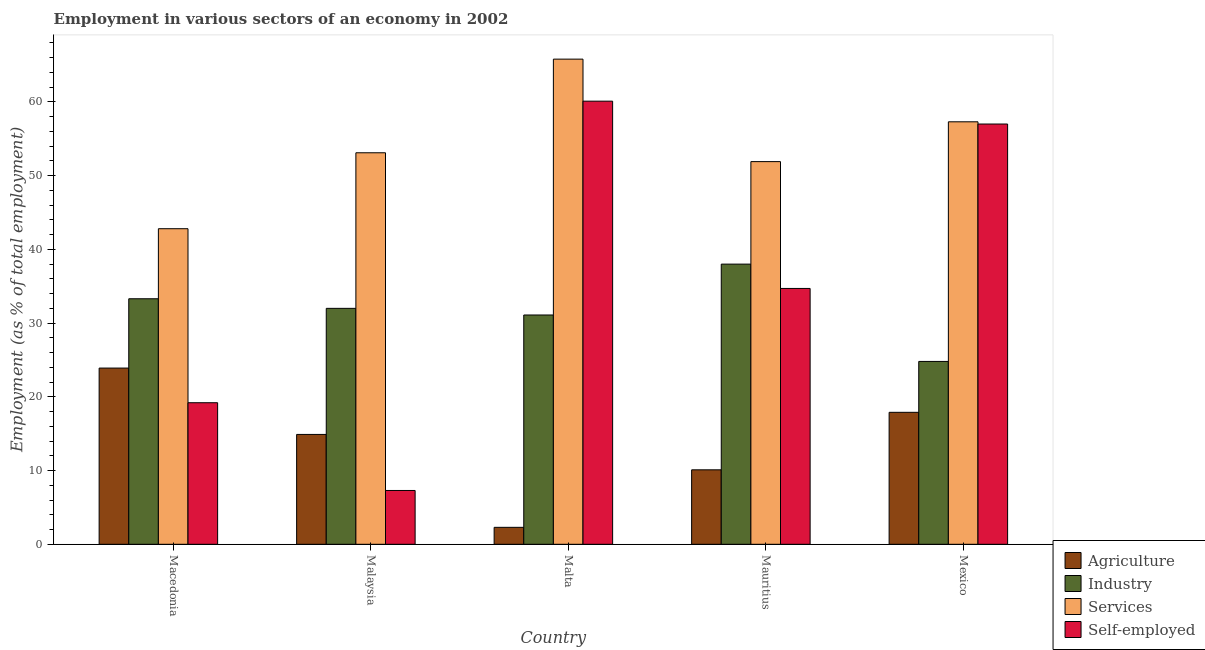How many groups of bars are there?
Provide a succinct answer. 5. Are the number of bars on each tick of the X-axis equal?
Your answer should be very brief. Yes. How many bars are there on the 1st tick from the right?
Your answer should be very brief. 4. What is the label of the 3rd group of bars from the left?
Offer a terse response. Malta. In how many cases, is the number of bars for a given country not equal to the number of legend labels?
Ensure brevity in your answer.  0. What is the percentage of self employed workers in Macedonia?
Provide a short and direct response. 19.2. Across all countries, what is the maximum percentage of self employed workers?
Provide a short and direct response. 60.1. Across all countries, what is the minimum percentage of self employed workers?
Your answer should be very brief. 7.3. In which country was the percentage of workers in industry maximum?
Your answer should be compact. Mauritius. In which country was the percentage of workers in agriculture minimum?
Keep it short and to the point. Malta. What is the total percentage of workers in agriculture in the graph?
Your response must be concise. 69.1. What is the difference between the percentage of self employed workers in Mauritius and that in Mexico?
Provide a short and direct response. -22.3. What is the difference between the percentage of self employed workers in Mexico and the percentage of workers in agriculture in Macedonia?
Provide a short and direct response. 33.1. What is the average percentage of workers in services per country?
Provide a short and direct response. 54.18. What is the difference between the percentage of workers in industry and percentage of workers in agriculture in Mexico?
Offer a terse response. 6.9. In how many countries, is the percentage of workers in agriculture greater than 54 %?
Keep it short and to the point. 0. What is the ratio of the percentage of workers in services in Macedonia to that in Mauritius?
Give a very brief answer. 0.82. Is the percentage of self employed workers in Malaysia less than that in Mauritius?
Offer a terse response. Yes. Is the difference between the percentage of workers in agriculture in Mauritius and Mexico greater than the difference between the percentage of workers in industry in Mauritius and Mexico?
Ensure brevity in your answer.  No. What is the difference between the highest and the second highest percentage of workers in industry?
Offer a terse response. 4.7. What is the difference between the highest and the lowest percentage of self employed workers?
Your response must be concise. 52.8. What does the 1st bar from the left in Macedonia represents?
Give a very brief answer. Agriculture. What does the 3rd bar from the right in Malta represents?
Provide a short and direct response. Industry. Is it the case that in every country, the sum of the percentage of workers in agriculture and percentage of workers in industry is greater than the percentage of workers in services?
Offer a very short reply. No. How many bars are there?
Provide a succinct answer. 20. Are all the bars in the graph horizontal?
Make the answer very short. No. How many countries are there in the graph?
Provide a short and direct response. 5. Are the values on the major ticks of Y-axis written in scientific E-notation?
Ensure brevity in your answer.  No. Does the graph contain grids?
Provide a short and direct response. No. How many legend labels are there?
Provide a short and direct response. 4. What is the title of the graph?
Keep it short and to the point. Employment in various sectors of an economy in 2002. What is the label or title of the X-axis?
Give a very brief answer. Country. What is the label or title of the Y-axis?
Provide a short and direct response. Employment (as % of total employment). What is the Employment (as % of total employment) in Agriculture in Macedonia?
Offer a terse response. 23.9. What is the Employment (as % of total employment) of Industry in Macedonia?
Offer a terse response. 33.3. What is the Employment (as % of total employment) of Services in Macedonia?
Offer a very short reply. 42.8. What is the Employment (as % of total employment) of Self-employed in Macedonia?
Your answer should be very brief. 19.2. What is the Employment (as % of total employment) in Agriculture in Malaysia?
Make the answer very short. 14.9. What is the Employment (as % of total employment) in Industry in Malaysia?
Your answer should be very brief. 32. What is the Employment (as % of total employment) in Services in Malaysia?
Give a very brief answer. 53.1. What is the Employment (as % of total employment) of Self-employed in Malaysia?
Offer a very short reply. 7.3. What is the Employment (as % of total employment) in Agriculture in Malta?
Your response must be concise. 2.3. What is the Employment (as % of total employment) of Industry in Malta?
Ensure brevity in your answer.  31.1. What is the Employment (as % of total employment) in Services in Malta?
Offer a terse response. 65.8. What is the Employment (as % of total employment) in Self-employed in Malta?
Keep it short and to the point. 60.1. What is the Employment (as % of total employment) in Agriculture in Mauritius?
Your answer should be very brief. 10.1. What is the Employment (as % of total employment) in Industry in Mauritius?
Offer a terse response. 38. What is the Employment (as % of total employment) of Services in Mauritius?
Make the answer very short. 51.9. What is the Employment (as % of total employment) of Self-employed in Mauritius?
Keep it short and to the point. 34.7. What is the Employment (as % of total employment) of Agriculture in Mexico?
Make the answer very short. 17.9. What is the Employment (as % of total employment) of Industry in Mexico?
Keep it short and to the point. 24.8. What is the Employment (as % of total employment) of Services in Mexico?
Offer a very short reply. 57.3. What is the Employment (as % of total employment) of Self-employed in Mexico?
Offer a terse response. 57. Across all countries, what is the maximum Employment (as % of total employment) in Agriculture?
Offer a terse response. 23.9. Across all countries, what is the maximum Employment (as % of total employment) in Industry?
Provide a succinct answer. 38. Across all countries, what is the maximum Employment (as % of total employment) of Services?
Give a very brief answer. 65.8. Across all countries, what is the maximum Employment (as % of total employment) in Self-employed?
Your response must be concise. 60.1. Across all countries, what is the minimum Employment (as % of total employment) of Agriculture?
Make the answer very short. 2.3. Across all countries, what is the minimum Employment (as % of total employment) of Industry?
Your answer should be very brief. 24.8. Across all countries, what is the minimum Employment (as % of total employment) of Services?
Provide a succinct answer. 42.8. Across all countries, what is the minimum Employment (as % of total employment) of Self-employed?
Provide a short and direct response. 7.3. What is the total Employment (as % of total employment) in Agriculture in the graph?
Ensure brevity in your answer.  69.1. What is the total Employment (as % of total employment) in Industry in the graph?
Make the answer very short. 159.2. What is the total Employment (as % of total employment) in Services in the graph?
Provide a short and direct response. 270.9. What is the total Employment (as % of total employment) in Self-employed in the graph?
Your response must be concise. 178.3. What is the difference between the Employment (as % of total employment) of Agriculture in Macedonia and that in Malaysia?
Keep it short and to the point. 9. What is the difference between the Employment (as % of total employment) of Self-employed in Macedonia and that in Malaysia?
Ensure brevity in your answer.  11.9. What is the difference between the Employment (as % of total employment) in Agriculture in Macedonia and that in Malta?
Provide a succinct answer. 21.6. What is the difference between the Employment (as % of total employment) of Industry in Macedonia and that in Malta?
Your response must be concise. 2.2. What is the difference between the Employment (as % of total employment) of Self-employed in Macedonia and that in Malta?
Keep it short and to the point. -40.9. What is the difference between the Employment (as % of total employment) in Services in Macedonia and that in Mauritius?
Provide a succinct answer. -9.1. What is the difference between the Employment (as % of total employment) of Self-employed in Macedonia and that in Mauritius?
Provide a short and direct response. -15.5. What is the difference between the Employment (as % of total employment) of Agriculture in Macedonia and that in Mexico?
Your answer should be compact. 6. What is the difference between the Employment (as % of total employment) of Industry in Macedonia and that in Mexico?
Offer a very short reply. 8.5. What is the difference between the Employment (as % of total employment) of Services in Macedonia and that in Mexico?
Offer a terse response. -14.5. What is the difference between the Employment (as % of total employment) of Self-employed in Macedonia and that in Mexico?
Keep it short and to the point. -37.8. What is the difference between the Employment (as % of total employment) in Industry in Malaysia and that in Malta?
Your answer should be very brief. 0.9. What is the difference between the Employment (as % of total employment) in Services in Malaysia and that in Malta?
Your answer should be very brief. -12.7. What is the difference between the Employment (as % of total employment) in Self-employed in Malaysia and that in Malta?
Ensure brevity in your answer.  -52.8. What is the difference between the Employment (as % of total employment) in Industry in Malaysia and that in Mauritius?
Your response must be concise. -6. What is the difference between the Employment (as % of total employment) of Self-employed in Malaysia and that in Mauritius?
Provide a short and direct response. -27.4. What is the difference between the Employment (as % of total employment) in Self-employed in Malaysia and that in Mexico?
Provide a short and direct response. -49.7. What is the difference between the Employment (as % of total employment) in Agriculture in Malta and that in Mauritius?
Offer a very short reply. -7.8. What is the difference between the Employment (as % of total employment) in Industry in Malta and that in Mauritius?
Keep it short and to the point. -6.9. What is the difference between the Employment (as % of total employment) in Services in Malta and that in Mauritius?
Provide a succinct answer. 13.9. What is the difference between the Employment (as % of total employment) in Self-employed in Malta and that in Mauritius?
Your answer should be compact. 25.4. What is the difference between the Employment (as % of total employment) of Agriculture in Malta and that in Mexico?
Provide a succinct answer. -15.6. What is the difference between the Employment (as % of total employment) in Industry in Malta and that in Mexico?
Your answer should be compact. 6.3. What is the difference between the Employment (as % of total employment) of Services in Malta and that in Mexico?
Provide a short and direct response. 8.5. What is the difference between the Employment (as % of total employment) in Self-employed in Malta and that in Mexico?
Provide a short and direct response. 3.1. What is the difference between the Employment (as % of total employment) in Industry in Mauritius and that in Mexico?
Give a very brief answer. 13.2. What is the difference between the Employment (as % of total employment) in Services in Mauritius and that in Mexico?
Your answer should be compact. -5.4. What is the difference between the Employment (as % of total employment) of Self-employed in Mauritius and that in Mexico?
Your answer should be very brief. -22.3. What is the difference between the Employment (as % of total employment) of Agriculture in Macedonia and the Employment (as % of total employment) of Services in Malaysia?
Offer a terse response. -29.2. What is the difference between the Employment (as % of total employment) in Industry in Macedonia and the Employment (as % of total employment) in Services in Malaysia?
Your answer should be very brief. -19.8. What is the difference between the Employment (as % of total employment) in Industry in Macedonia and the Employment (as % of total employment) in Self-employed in Malaysia?
Offer a terse response. 26. What is the difference between the Employment (as % of total employment) of Services in Macedonia and the Employment (as % of total employment) of Self-employed in Malaysia?
Give a very brief answer. 35.5. What is the difference between the Employment (as % of total employment) in Agriculture in Macedonia and the Employment (as % of total employment) in Industry in Malta?
Give a very brief answer. -7.2. What is the difference between the Employment (as % of total employment) in Agriculture in Macedonia and the Employment (as % of total employment) in Services in Malta?
Give a very brief answer. -41.9. What is the difference between the Employment (as % of total employment) in Agriculture in Macedonia and the Employment (as % of total employment) in Self-employed in Malta?
Your response must be concise. -36.2. What is the difference between the Employment (as % of total employment) in Industry in Macedonia and the Employment (as % of total employment) in Services in Malta?
Make the answer very short. -32.5. What is the difference between the Employment (as % of total employment) in Industry in Macedonia and the Employment (as % of total employment) in Self-employed in Malta?
Make the answer very short. -26.8. What is the difference between the Employment (as % of total employment) in Services in Macedonia and the Employment (as % of total employment) in Self-employed in Malta?
Provide a succinct answer. -17.3. What is the difference between the Employment (as % of total employment) in Agriculture in Macedonia and the Employment (as % of total employment) in Industry in Mauritius?
Offer a terse response. -14.1. What is the difference between the Employment (as % of total employment) of Industry in Macedonia and the Employment (as % of total employment) of Services in Mauritius?
Provide a succinct answer. -18.6. What is the difference between the Employment (as % of total employment) of Industry in Macedonia and the Employment (as % of total employment) of Self-employed in Mauritius?
Keep it short and to the point. -1.4. What is the difference between the Employment (as % of total employment) in Services in Macedonia and the Employment (as % of total employment) in Self-employed in Mauritius?
Ensure brevity in your answer.  8.1. What is the difference between the Employment (as % of total employment) of Agriculture in Macedonia and the Employment (as % of total employment) of Industry in Mexico?
Offer a very short reply. -0.9. What is the difference between the Employment (as % of total employment) in Agriculture in Macedonia and the Employment (as % of total employment) in Services in Mexico?
Make the answer very short. -33.4. What is the difference between the Employment (as % of total employment) in Agriculture in Macedonia and the Employment (as % of total employment) in Self-employed in Mexico?
Provide a succinct answer. -33.1. What is the difference between the Employment (as % of total employment) of Industry in Macedonia and the Employment (as % of total employment) of Self-employed in Mexico?
Offer a very short reply. -23.7. What is the difference between the Employment (as % of total employment) in Services in Macedonia and the Employment (as % of total employment) in Self-employed in Mexico?
Provide a succinct answer. -14.2. What is the difference between the Employment (as % of total employment) in Agriculture in Malaysia and the Employment (as % of total employment) in Industry in Malta?
Offer a terse response. -16.2. What is the difference between the Employment (as % of total employment) of Agriculture in Malaysia and the Employment (as % of total employment) of Services in Malta?
Your answer should be compact. -50.9. What is the difference between the Employment (as % of total employment) in Agriculture in Malaysia and the Employment (as % of total employment) in Self-employed in Malta?
Make the answer very short. -45.2. What is the difference between the Employment (as % of total employment) of Industry in Malaysia and the Employment (as % of total employment) of Services in Malta?
Your answer should be compact. -33.8. What is the difference between the Employment (as % of total employment) of Industry in Malaysia and the Employment (as % of total employment) of Self-employed in Malta?
Provide a succinct answer. -28.1. What is the difference between the Employment (as % of total employment) of Agriculture in Malaysia and the Employment (as % of total employment) of Industry in Mauritius?
Your answer should be compact. -23.1. What is the difference between the Employment (as % of total employment) in Agriculture in Malaysia and the Employment (as % of total employment) in Services in Mauritius?
Keep it short and to the point. -37. What is the difference between the Employment (as % of total employment) of Agriculture in Malaysia and the Employment (as % of total employment) of Self-employed in Mauritius?
Your answer should be compact. -19.8. What is the difference between the Employment (as % of total employment) in Industry in Malaysia and the Employment (as % of total employment) in Services in Mauritius?
Make the answer very short. -19.9. What is the difference between the Employment (as % of total employment) of Industry in Malaysia and the Employment (as % of total employment) of Self-employed in Mauritius?
Offer a very short reply. -2.7. What is the difference between the Employment (as % of total employment) of Agriculture in Malaysia and the Employment (as % of total employment) of Services in Mexico?
Keep it short and to the point. -42.4. What is the difference between the Employment (as % of total employment) of Agriculture in Malaysia and the Employment (as % of total employment) of Self-employed in Mexico?
Provide a succinct answer. -42.1. What is the difference between the Employment (as % of total employment) in Industry in Malaysia and the Employment (as % of total employment) in Services in Mexico?
Provide a short and direct response. -25.3. What is the difference between the Employment (as % of total employment) of Industry in Malaysia and the Employment (as % of total employment) of Self-employed in Mexico?
Your answer should be compact. -25. What is the difference between the Employment (as % of total employment) of Services in Malaysia and the Employment (as % of total employment) of Self-employed in Mexico?
Provide a short and direct response. -3.9. What is the difference between the Employment (as % of total employment) of Agriculture in Malta and the Employment (as % of total employment) of Industry in Mauritius?
Provide a short and direct response. -35.7. What is the difference between the Employment (as % of total employment) in Agriculture in Malta and the Employment (as % of total employment) in Services in Mauritius?
Offer a terse response. -49.6. What is the difference between the Employment (as % of total employment) in Agriculture in Malta and the Employment (as % of total employment) in Self-employed in Mauritius?
Provide a succinct answer. -32.4. What is the difference between the Employment (as % of total employment) in Industry in Malta and the Employment (as % of total employment) in Services in Mauritius?
Offer a very short reply. -20.8. What is the difference between the Employment (as % of total employment) in Industry in Malta and the Employment (as % of total employment) in Self-employed in Mauritius?
Provide a succinct answer. -3.6. What is the difference between the Employment (as % of total employment) of Services in Malta and the Employment (as % of total employment) of Self-employed in Mauritius?
Offer a terse response. 31.1. What is the difference between the Employment (as % of total employment) in Agriculture in Malta and the Employment (as % of total employment) in Industry in Mexico?
Make the answer very short. -22.5. What is the difference between the Employment (as % of total employment) in Agriculture in Malta and the Employment (as % of total employment) in Services in Mexico?
Make the answer very short. -55. What is the difference between the Employment (as % of total employment) in Agriculture in Malta and the Employment (as % of total employment) in Self-employed in Mexico?
Keep it short and to the point. -54.7. What is the difference between the Employment (as % of total employment) of Industry in Malta and the Employment (as % of total employment) of Services in Mexico?
Give a very brief answer. -26.2. What is the difference between the Employment (as % of total employment) in Industry in Malta and the Employment (as % of total employment) in Self-employed in Mexico?
Make the answer very short. -25.9. What is the difference between the Employment (as % of total employment) of Services in Malta and the Employment (as % of total employment) of Self-employed in Mexico?
Provide a short and direct response. 8.8. What is the difference between the Employment (as % of total employment) in Agriculture in Mauritius and the Employment (as % of total employment) in Industry in Mexico?
Offer a terse response. -14.7. What is the difference between the Employment (as % of total employment) in Agriculture in Mauritius and the Employment (as % of total employment) in Services in Mexico?
Make the answer very short. -47.2. What is the difference between the Employment (as % of total employment) in Agriculture in Mauritius and the Employment (as % of total employment) in Self-employed in Mexico?
Provide a short and direct response. -46.9. What is the difference between the Employment (as % of total employment) of Industry in Mauritius and the Employment (as % of total employment) of Services in Mexico?
Your answer should be very brief. -19.3. What is the difference between the Employment (as % of total employment) in Industry in Mauritius and the Employment (as % of total employment) in Self-employed in Mexico?
Your response must be concise. -19. What is the difference between the Employment (as % of total employment) of Services in Mauritius and the Employment (as % of total employment) of Self-employed in Mexico?
Offer a terse response. -5.1. What is the average Employment (as % of total employment) of Agriculture per country?
Offer a very short reply. 13.82. What is the average Employment (as % of total employment) in Industry per country?
Your answer should be compact. 31.84. What is the average Employment (as % of total employment) of Services per country?
Your answer should be very brief. 54.18. What is the average Employment (as % of total employment) in Self-employed per country?
Give a very brief answer. 35.66. What is the difference between the Employment (as % of total employment) of Agriculture and Employment (as % of total employment) of Industry in Macedonia?
Your response must be concise. -9.4. What is the difference between the Employment (as % of total employment) in Agriculture and Employment (as % of total employment) in Services in Macedonia?
Give a very brief answer. -18.9. What is the difference between the Employment (as % of total employment) of Industry and Employment (as % of total employment) of Services in Macedonia?
Your answer should be very brief. -9.5. What is the difference between the Employment (as % of total employment) in Industry and Employment (as % of total employment) in Self-employed in Macedonia?
Provide a succinct answer. 14.1. What is the difference between the Employment (as % of total employment) in Services and Employment (as % of total employment) in Self-employed in Macedonia?
Offer a very short reply. 23.6. What is the difference between the Employment (as % of total employment) of Agriculture and Employment (as % of total employment) of Industry in Malaysia?
Provide a succinct answer. -17.1. What is the difference between the Employment (as % of total employment) of Agriculture and Employment (as % of total employment) of Services in Malaysia?
Provide a short and direct response. -38.2. What is the difference between the Employment (as % of total employment) of Agriculture and Employment (as % of total employment) of Self-employed in Malaysia?
Your response must be concise. 7.6. What is the difference between the Employment (as % of total employment) in Industry and Employment (as % of total employment) in Services in Malaysia?
Provide a succinct answer. -21.1. What is the difference between the Employment (as % of total employment) in Industry and Employment (as % of total employment) in Self-employed in Malaysia?
Offer a terse response. 24.7. What is the difference between the Employment (as % of total employment) in Services and Employment (as % of total employment) in Self-employed in Malaysia?
Keep it short and to the point. 45.8. What is the difference between the Employment (as % of total employment) in Agriculture and Employment (as % of total employment) in Industry in Malta?
Keep it short and to the point. -28.8. What is the difference between the Employment (as % of total employment) of Agriculture and Employment (as % of total employment) of Services in Malta?
Ensure brevity in your answer.  -63.5. What is the difference between the Employment (as % of total employment) of Agriculture and Employment (as % of total employment) of Self-employed in Malta?
Ensure brevity in your answer.  -57.8. What is the difference between the Employment (as % of total employment) of Industry and Employment (as % of total employment) of Services in Malta?
Your answer should be compact. -34.7. What is the difference between the Employment (as % of total employment) in Industry and Employment (as % of total employment) in Self-employed in Malta?
Your response must be concise. -29. What is the difference between the Employment (as % of total employment) in Services and Employment (as % of total employment) in Self-employed in Malta?
Your answer should be very brief. 5.7. What is the difference between the Employment (as % of total employment) of Agriculture and Employment (as % of total employment) of Industry in Mauritius?
Provide a short and direct response. -27.9. What is the difference between the Employment (as % of total employment) in Agriculture and Employment (as % of total employment) in Services in Mauritius?
Offer a terse response. -41.8. What is the difference between the Employment (as % of total employment) of Agriculture and Employment (as % of total employment) of Self-employed in Mauritius?
Offer a terse response. -24.6. What is the difference between the Employment (as % of total employment) in Industry and Employment (as % of total employment) in Services in Mauritius?
Your answer should be very brief. -13.9. What is the difference between the Employment (as % of total employment) of Industry and Employment (as % of total employment) of Self-employed in Mauritius?
Offer a terse response. 3.3. What is the difference between the Employment (as % of total employment) in Agriculture and Employment (as % of total employment) in Industry in Mexico?
Offer a very short reply. -6.9. What is the difference between the Employment (as % of total employment) of Agriculture and Employment (as % of total employment) of Services in Mexico?
Your response must be concise. -39.4. What is the difference between the Employment (as % of total employment) of Agriculture and Employment (as % of total employment) of Self-employed in Mexico?
Offer a terse response. -39.1. What is the difference between the Employment (as % of total employment) in Industry and Employment (as % of total employment) in Services in Mexico?
Offer a very short reply. -32.5. What is the difference between the Employment (as % of total employment) in Industry and Employment (as % of total employment) in Self-employed in Mexico?
Ensure brevity in your answer.  -32.2. What is the difference between the Employment (as % of total employment) in Services and Employment (as % of total employment) in Self-employed in Mexico?
Provide a succinct answer. 0.3. What is the ratio of the Employment (as % of total employment) in Agriculture in Macedonia to that in Malaysia?
Your response must be concise. 1.6. What is the ratio of the Employment (as % of total employment) of Industry in Macedonia to that in Malaysia?
Offer a very short reply. 1.04. What is the ratio of the Employment (as % of total employment) of Services in Macedonia to that in Malaysia?
Give a very brief answer. 0.81. What is the ratio of the Employment (as % of total employment) in Self-employed in Macedonia to that in Malaysia?
Make the answer very short. 2.63. What is the ratio of the Employment (as % of total employment) of Agriculture in Macedonia to that in Malta?
Offer a very short reply. 10.39. What is the ratio of the Employment (as % of total employment) of Industry in Macedonia to that in Malta?
Make the answer very short. 1.07. What is the ratio of the Employment (as % of total employment) in Services in Macedonia to that in Malta?
Offer a terse response. 0.65. What is the ratio of the Employment (as % of total employment) in Self-employed in Macedonia to that in Malta?
Provide a succinct answer. 0.32. What is the ratio of the Employment (as % of total employment) of Agriculture in Macedonia to that in Mauritius?
Ensure brevity in your answer.  2.37. What is the ratio of the Employment (as % of total employment) of Industry in Macedonia to that in Mauritius?
Keep it short and to the point. 0.88. What is the ratio of the Employment (as % of total employment) in Services in Macedonia to that in Mauritius?
Your answer should be compact. 0.82. What is the ratio of the Employment (as % of total employment) of Self-employed in Macedonia to that in Mauritius?
Provide a succinct answer. 0.55. What is the ratio of the Employment (as % of total employment) in Agriculture in Macedonia to that in Mexico?
Give a very brief answer. 1.34. What is the ratio of the Employment (as % of total employment) of Industry in Macedonia to that in Mexico?
Provide a succinct answer. 1.34. What is the ratio of the Employment (as % of total employment) in Services in Macedonia to that in Mexico?
Your answer should be compact. 0.75. What is the ratio of the Employment (as % of total employment) in Self-employed in Macedonia to that in Mexico?
Offer a very short reply. 0.34. What is the ratio of the Employment (as % of total employment) in Agriculture in Malaysia to that in Malta?
Ensure brevity in your answer.  6.48. What is the ratio of the Employment (as % of total employment) of Industry in Malaysia to that in Malta?
Offer a very short reply. 1.03. What is the ratio of the Employment (as % of total employment) of Services in Malaysia to that in Malta?
Give a very brief answer. 0.81. What is the ratio of the Employment (as % of total employment) in Self-employed in Malaysia to that in Malta?
Make the answer very short. 0.12. What is the ratio of the Employment (as % of total employment) in Agriculture in Malaysia to that in Mauritius?
Ensure brevity in your answer.  1.48. What is the ratio of the Employment (as % of total employment) of Industry in Malaysia to that in Mauritius?
Offer a very short reply. 0.84. What is the ratio of the Employment (as % of total employment) of Services in Malaysia to that in Mauritius?
Give a very brief answer. 1.02. What is the ratio of the Employment (as % of total employment) in Self-employed in Malaysia to that in Mauritius?
Make the answer very short. 0.21. What is the ratio of the Employment (as % of total employment) in Agriculture in Malaysia to that in Mexico?
Offer a very short reply. 0.83. What is the ratio of the Employment (as % of total employment) of Industry in Malaysia to that in Mexico?
Offer a very short reply. 1.29. What is the ratio of the Employment (as % of total employment) of Services in Malaysia to that in Mexico?
Provide a succinct answer. 0.93. What is the ratio of the Employment (as % of total employment) of Self-employed in Malaysia to that in Mexico?
Offer a terse response. 0.13. What is the ratio of the Employment (as % of total employment) in Agriculture in Malta to that in Mauritius?
Your answer should be very brief. 0.23. What is the ratio of the Employment (as % of total employment) in Industry in Malta to that in Mauritius?
Offer a terse response. 0.82. What is the ratio of the Employment (as % of total employment) in Services in Malta to that in Mauritius?
Offer a very short reply. 1.27. What is the ratio of the Employment (as % of total employment) in Self-employed in Malta to that in Mauritius?
Ensure brevity in your answer.  1.73. What is the ratio of the Employment (as % of total employment) of Agriculture in Malta to that in Mexico?
Provide a short and direct response. 0.13. What is the ratio of the Employment (as % of total employment) of Industry in Malta to that in Mexico?
Keep it short and to the point. 1.25. What is the ratio of the Employment (as % of total employment) in Services in Malta to that in Mexico?
Make the answer very short. 1.15. What is the ratio of the Employment (as % of total employment) in Self-employed in Malta to that in Mexico?
Your answer should be compact. 1.05. What is the ratio of the Employment (as % of total employment) in Agriculture in Mauritius to that in Mexico?
Keep it short and to the point. 0.56. What is the ratio of the Employment (as % of total employment) in Industry in Mauritius to that in Mexico?
Provide a short and direct response. 1.53. What is the ratio of the Employment (as % of total employment) in Services in Mauritius to that in Mexico?
Offer a terse response. 0.91. What is the ratio of the Employment (as % of total employment) in Self-employed in Mauritius to that in Mexico?
Provide a succinct answer. 0.61. What is the difference between the highest and the second highest Employment (as % of total employment) of Agriculture?
Your response must be concise. 6. What is the difference between the highest and the second highest Employment (as % of total employment) in Services?
Your response must be concise. 8.5. What is the difference between the highest and the second highest Employment (as % of total employment) of Self-employed?
Keep it short and to the point. 3.1. What is the difference between the highest and the lowest Employment (as % of total employment) in Agriculture?
Keep it short and to the point. 21.6. What is the difference between the highest and the lowest Employment (as % of total employment) in Industry?
Your answer should be very brief. 13.2. What is the difference between the highest and the lowest Employment (as % of total employment) in Services?
Make the answer very short. 23. What is the difference between the highest and the lowest Employment (as % of total employment) of Self-employed?
Ensure brevity in your answer.  52.8. 